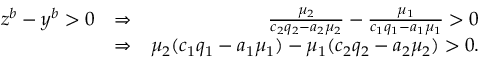Convert formula to latex. <formula><loc_0><loc_0><loc_500><loc_500>\begin{array} { r l r } { z ^ { b } - y ^ { b } > 0 } & { \Rightarrow } & { \frac { \mu _ { 2 } } { c _ { 2 } q _ { 2 } - a _ { 2 } \mu _ { 2 } } - \frac { \mu _ { 1 } } { c _ { 1 } q _ { 1 } - a _ { 1 } \mu _ { 1 } } > 0 } \\ & { \Rightarrow } & { \mu _ { 2 } ( c _ { 1 } q _ { 1 } - a _ { 1 } \mu _ { 1 } ) - \mu _ { 1 } ( c _ { 2 } q _ { 2 } - a _ { 2 } \mu _ { 2 } ) > 0 . } \end{array}</formula> 